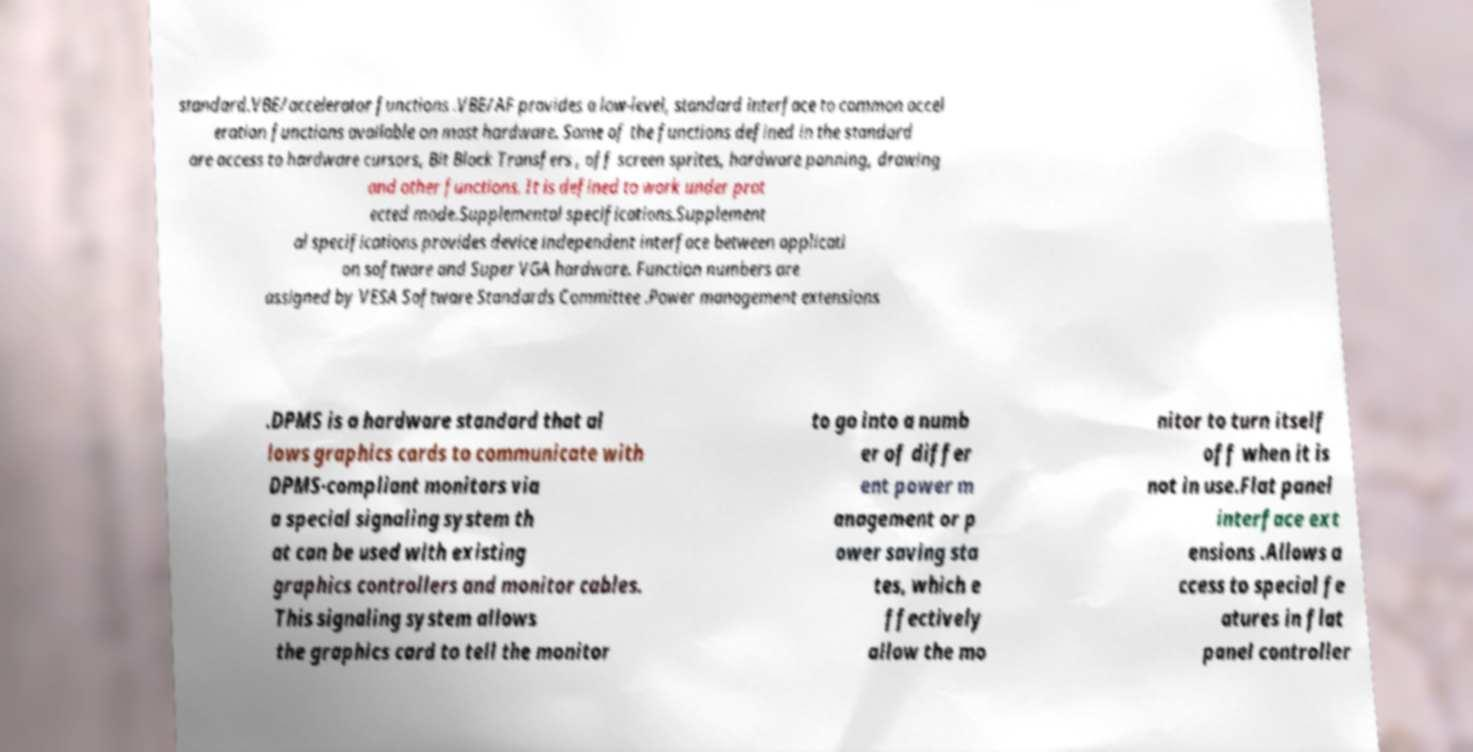For documentation purposes, I need the text within this image transcribed. Could you provide that? standard.VBE/accelerator functions .VBE/AF provides a low-level, standard interface to common accel eration functions available on most hardware. Some of the functions defined in the standard are access to hardware cursors, Bit Block Transfers , off screen sprites, hardware panning, drawing and other functions. It is defined to work under prot ected mode.Supplemental specifications.Supplement al specifications provides device independent interface between applicati on software and Super VGA hardware. Function numbers are assigned by VESA Software Standards Committee .Power management extensions .DPMS is a hardware standard that al lows graphics cards to communicate with DPMS-compliant monitors via a special signaling system th at can be used with existing graphics controllers and monitor cables. This signaling system allows the graphics card to tell the monitor to go into a numb er of differ ent power m anagement or p ower saving sta tes, which e ffectively allow the mo nitor to turn itself off when it is not in use.Flat panel interface ext ensions .Allows a ccess to special fe atures in flat panel controller 